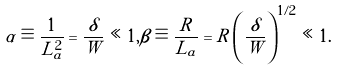Convert formula to latex. <formula><loc_0><loc_0><loc_500><loc_500>\alpha \equiv \frac { 1 } { L _ { a } ^ { 2 } } = \frac { \delta } { W } \ll 1 , \beta \equiv \frac { R } { L _ { a } } = R \left ( \frac { \delta } { W } \right ) ^ { 1 / 2 } \ll 1 .</formula> 